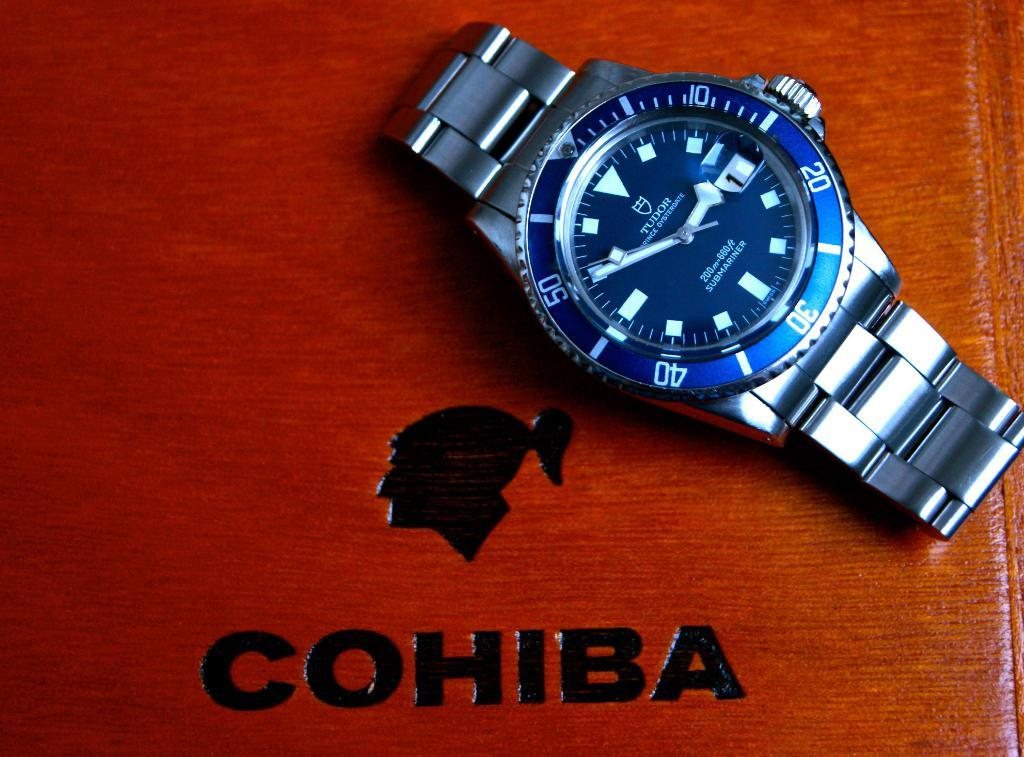Provide a one-sentence caption for the provided image. A nice Tudor watch with a stainless steel watchband and cobalt blue watch face sitting on a wood Cohiba box. 